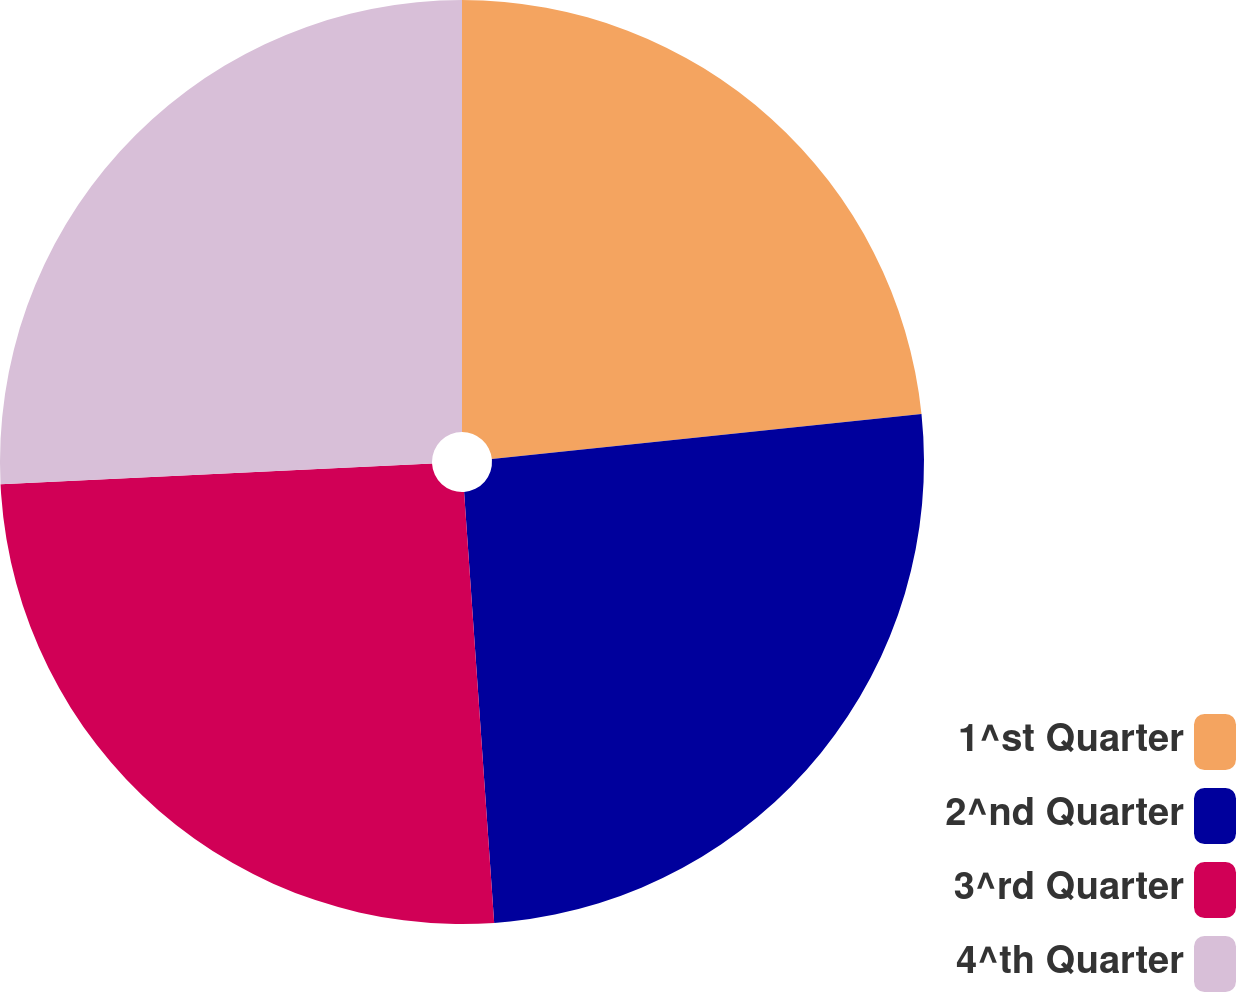Convert chart to OTSL. <chart><loc_0><loc_0><loc_500><loc_500><pie_chart><fcel>1^st Quarter<fcel>2^nd Quarter<fcel>3^rd Quarter<fcel>4^th Quarter<nl><fcel>23.34%<fcel>25.55%<fcel>25.34%<fcel>25.77%<nl></chart> 